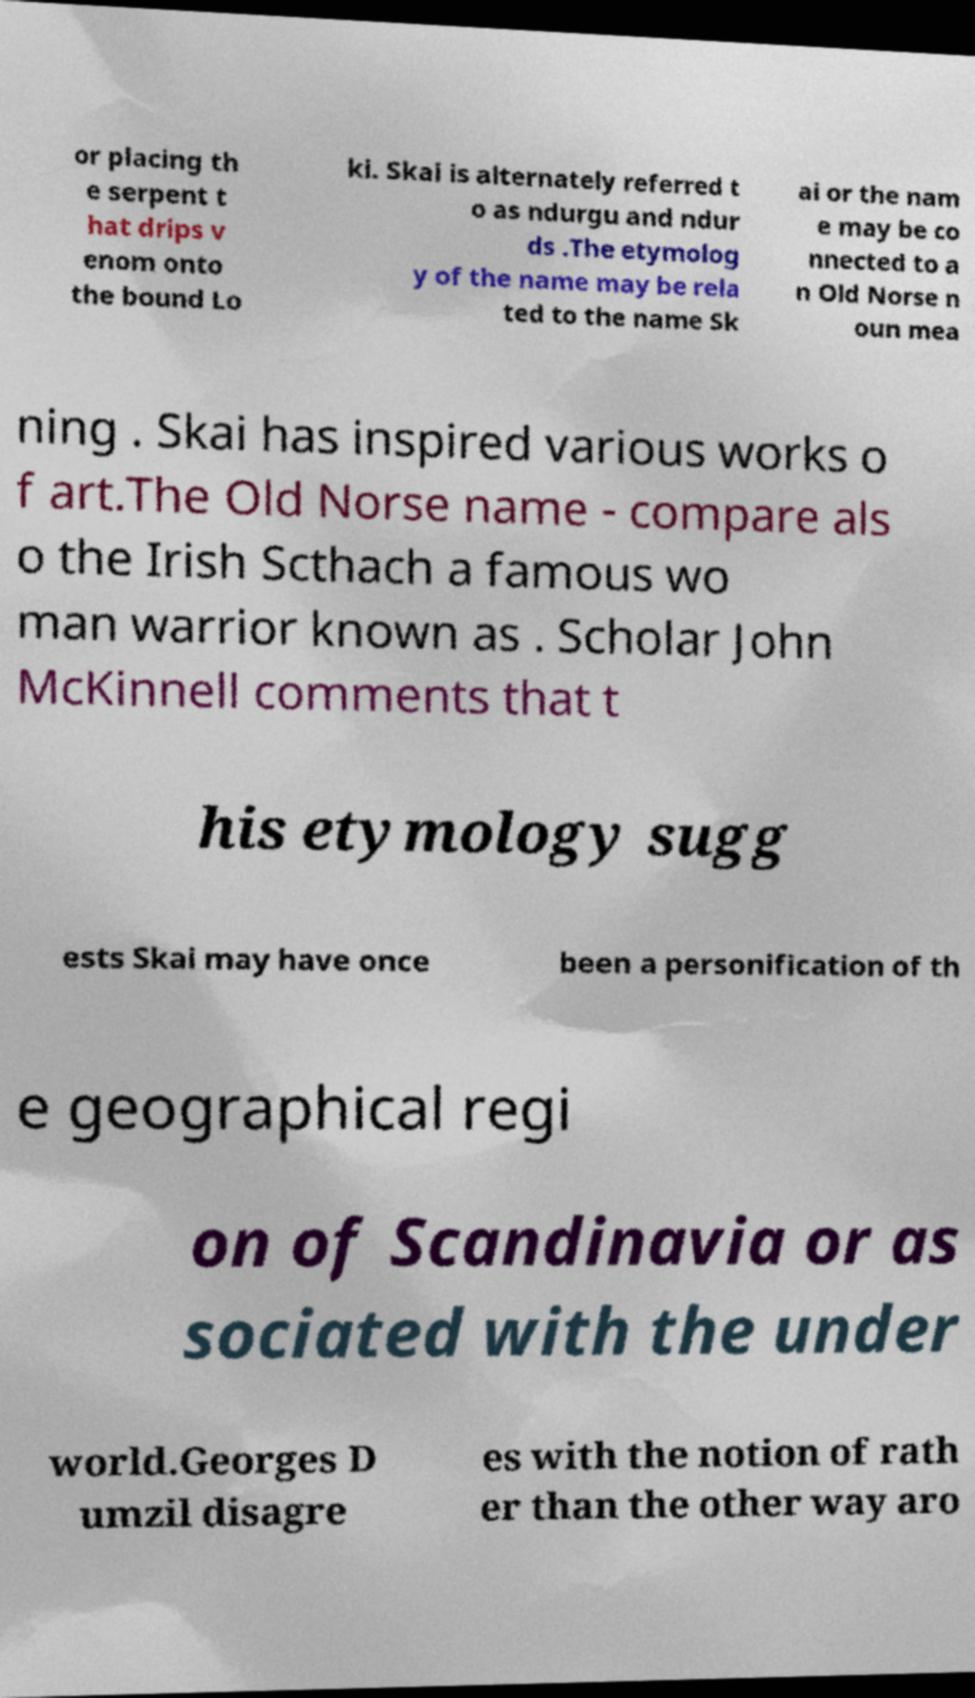Please identify and transcribe the text found in this image. or placing th e serpent t hat drips v enom onto the bound Lo ki. Skai is alternately referred t o as ndurgu and ndur ds .The etymolog y of the name may be rela ted to the name Sk ai or the nam e may be co nnected to a n Old Norse n oun mea ning . Skai has inspired various works o f art.The Old Norse name - compare als o the Irish Scthach a famous wo man warrior known as . Scholar John McKinnell comments that t his etymology sugg ests Skai may have once been a personification of th e geographical regi on of Scandinavia or as sociated with the under world.Georges D umzil disagre es with the notion of rath er than the other way aro 